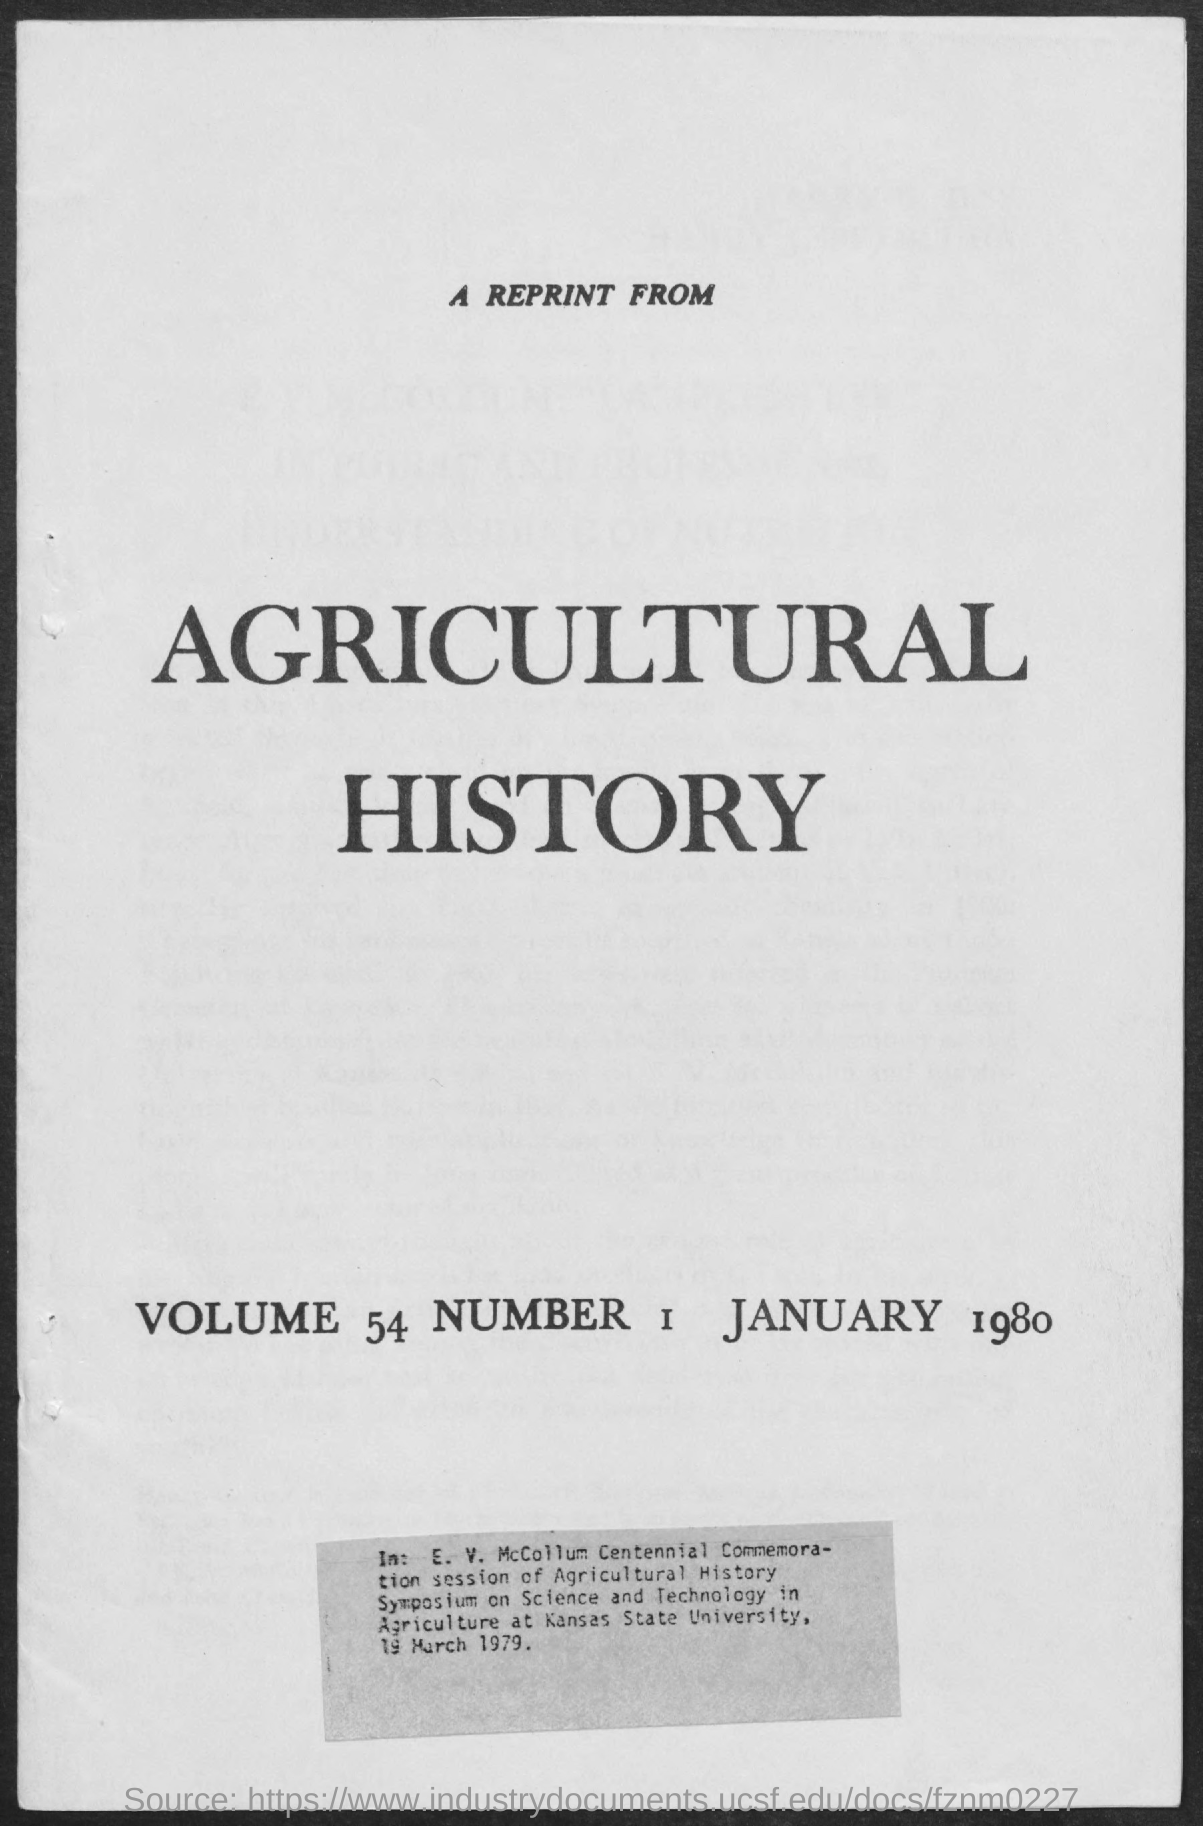Draw attention to some important aspects in this diagram. The date mentioned is January 1980. The heading in the given form is 'Agricultural History.' The volume number mentioned is 54. The number mentioned is 1. 